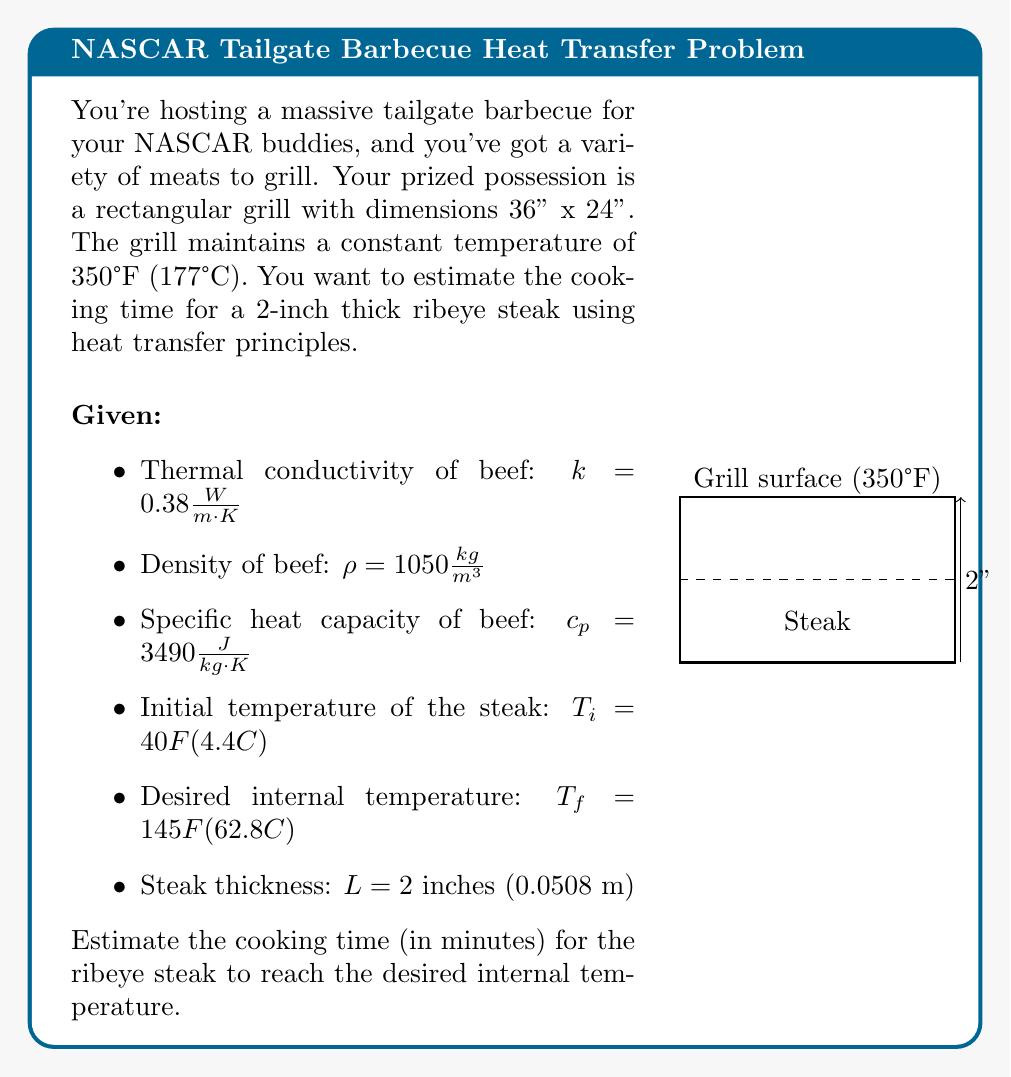Provide a solution to this math problem. To estimate the cooking time, we'll use the principles of heat transfer and the concept of thermal diffusivity. We'll follow these steps:

1) First, calculate the thermal diffusivity ($\alpha$) of the beef:

   $$\alpha = \frac{k}{\rho c_p} = \frac{0.38}{1050 \cdot 3490} = 1.03 \times 10^{-7} \frac{m^2}{s}$$

2) The characteristic time ($t_c$) for heat to diffuse through the steak is given by:

   $$t_c = \frac{L^2}{\alpha}$$

3) Substitute the values:

   $$t_c = \frac{(0.0508)^2}{1.03 \times 10^{-7}} = 25,030 \text{ seconds}$$

4) The temperature distribution in the steak can be approximated by:

   $$\frac{T(t) - T_i}{T_g - T_i} = 1 - e^{-t/t_c}$$

   Where $T_g$ is the grill temperature, $T_i$ is the initial steak temperature, and $T(t)$ is the steak temperature at time $t$.

5) Rearrange the equation to solve for $t$:

   $$t = -t_c \ln\left(1 - \frac{T(t) - T_i}{T_g - T_i}\right)$$

6) Substitute the values:

   $$t = -25,030 \ln\left(1 - \frac{62.8 - 4.4}{177 - 4.4}\right) = 13,816 \text{ seconds}$$

7) Convert to minutes:

   $$t = 13,816 \text{ seconds} \times \frac{1 \text{ minute}}{60 \text{ seconds}} = 230.3 \text{ minutes}$$
Answer: 230 minutes 